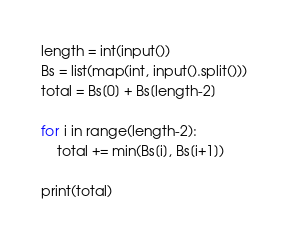Convert code to text. <code><loc_0><loc_0><loc_500><loc_500><_Python_>length = int(input())
Bs = list(map(int, input().split()))
total = Bs[0] + Bs[length-2]

for i in range(length-2):
    total += min(Bs[i], Bs[i+1])

print(total)</code> 